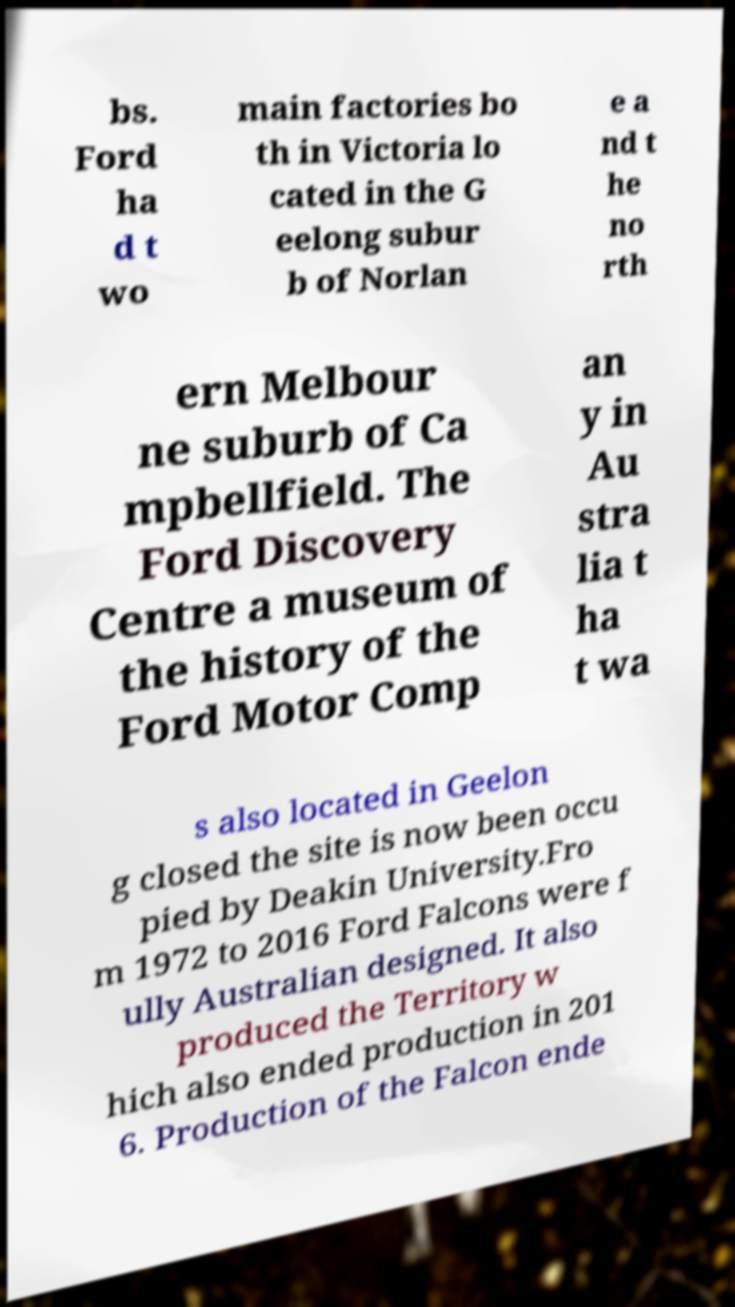What messages or text are displayed in this image? I need them in a readable, typed format. bs. Ford ha d t wo main factories bo th in Victoria lo cated in the G eelong subur b of Norlan e a nd t he no rth ern Melbour ne suburb of Ca mpbellfield. The Ford Discovery Centre a museum of the history of the Ford Motor Comp an y in Au stra lia t ha t wa s also located in Geelon g closed the site is now been occu pied by Deakin University.Fro m 1972 to 2016 Ford Falcons were f ully Australian designed. It also produced the Territory w hich also ended production in 201 6. Production of the Falcon ende 